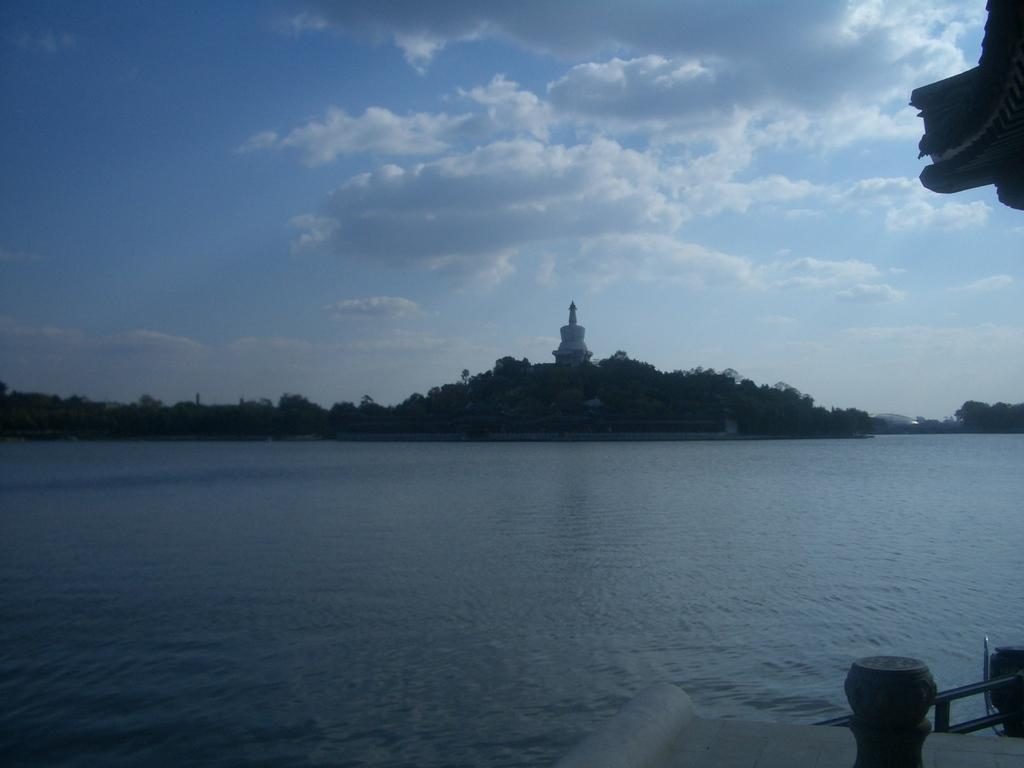What is the primary element visible in the image? There is water in the image. What type of material are the rods made of in the image? The rods in the image are made of metal. What type of vegetation can be seen in the image? There are trees in the image. What is visible in the background of the image? There is a tower and clouds visible in the background of the image. What type of cup is being used to drink hot chocolate in the image? There is no cup or hot chocolate present in the image. 